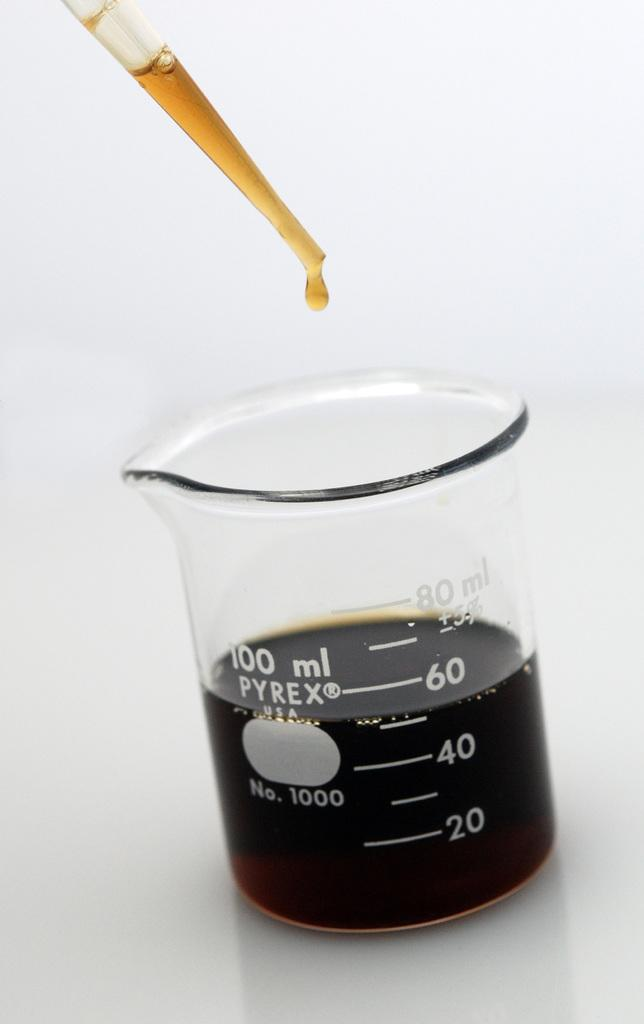<image>
Describe the image concisely. Clear measuring cup that measures 100 ml pyrex No. 1000. 